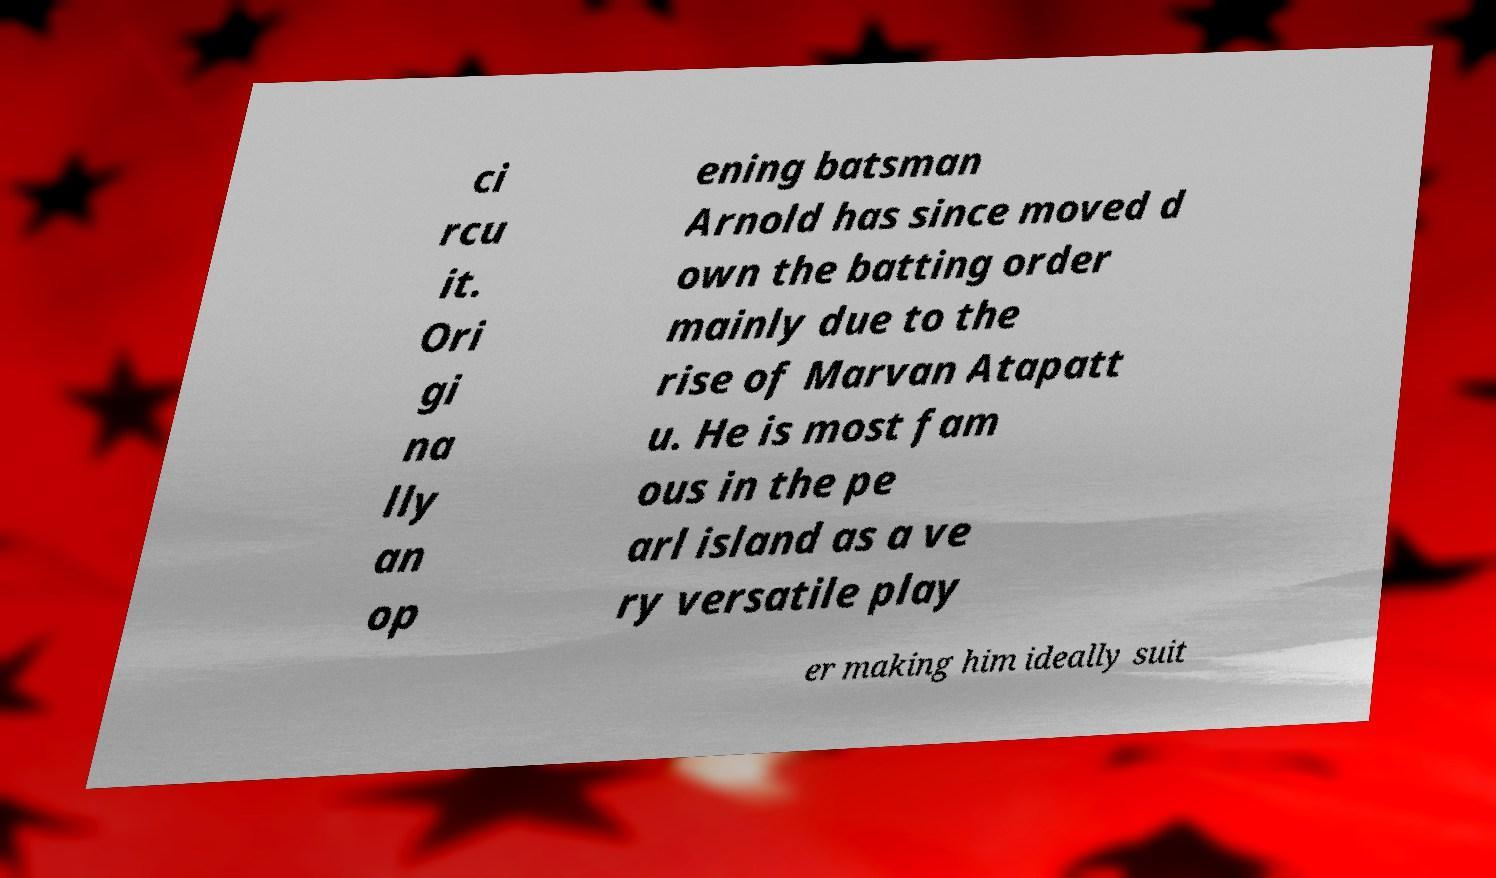I need the written content from this picture converted into text. Can you do that? ci rcu it. Ori gi na lly an op ening batsman Arnold has since moved d own the batting order mainly due to the rise of Marvan Atapatt u. He is most fam ous in the pe arl island as a ve ry versatile play er making him ideally suit 